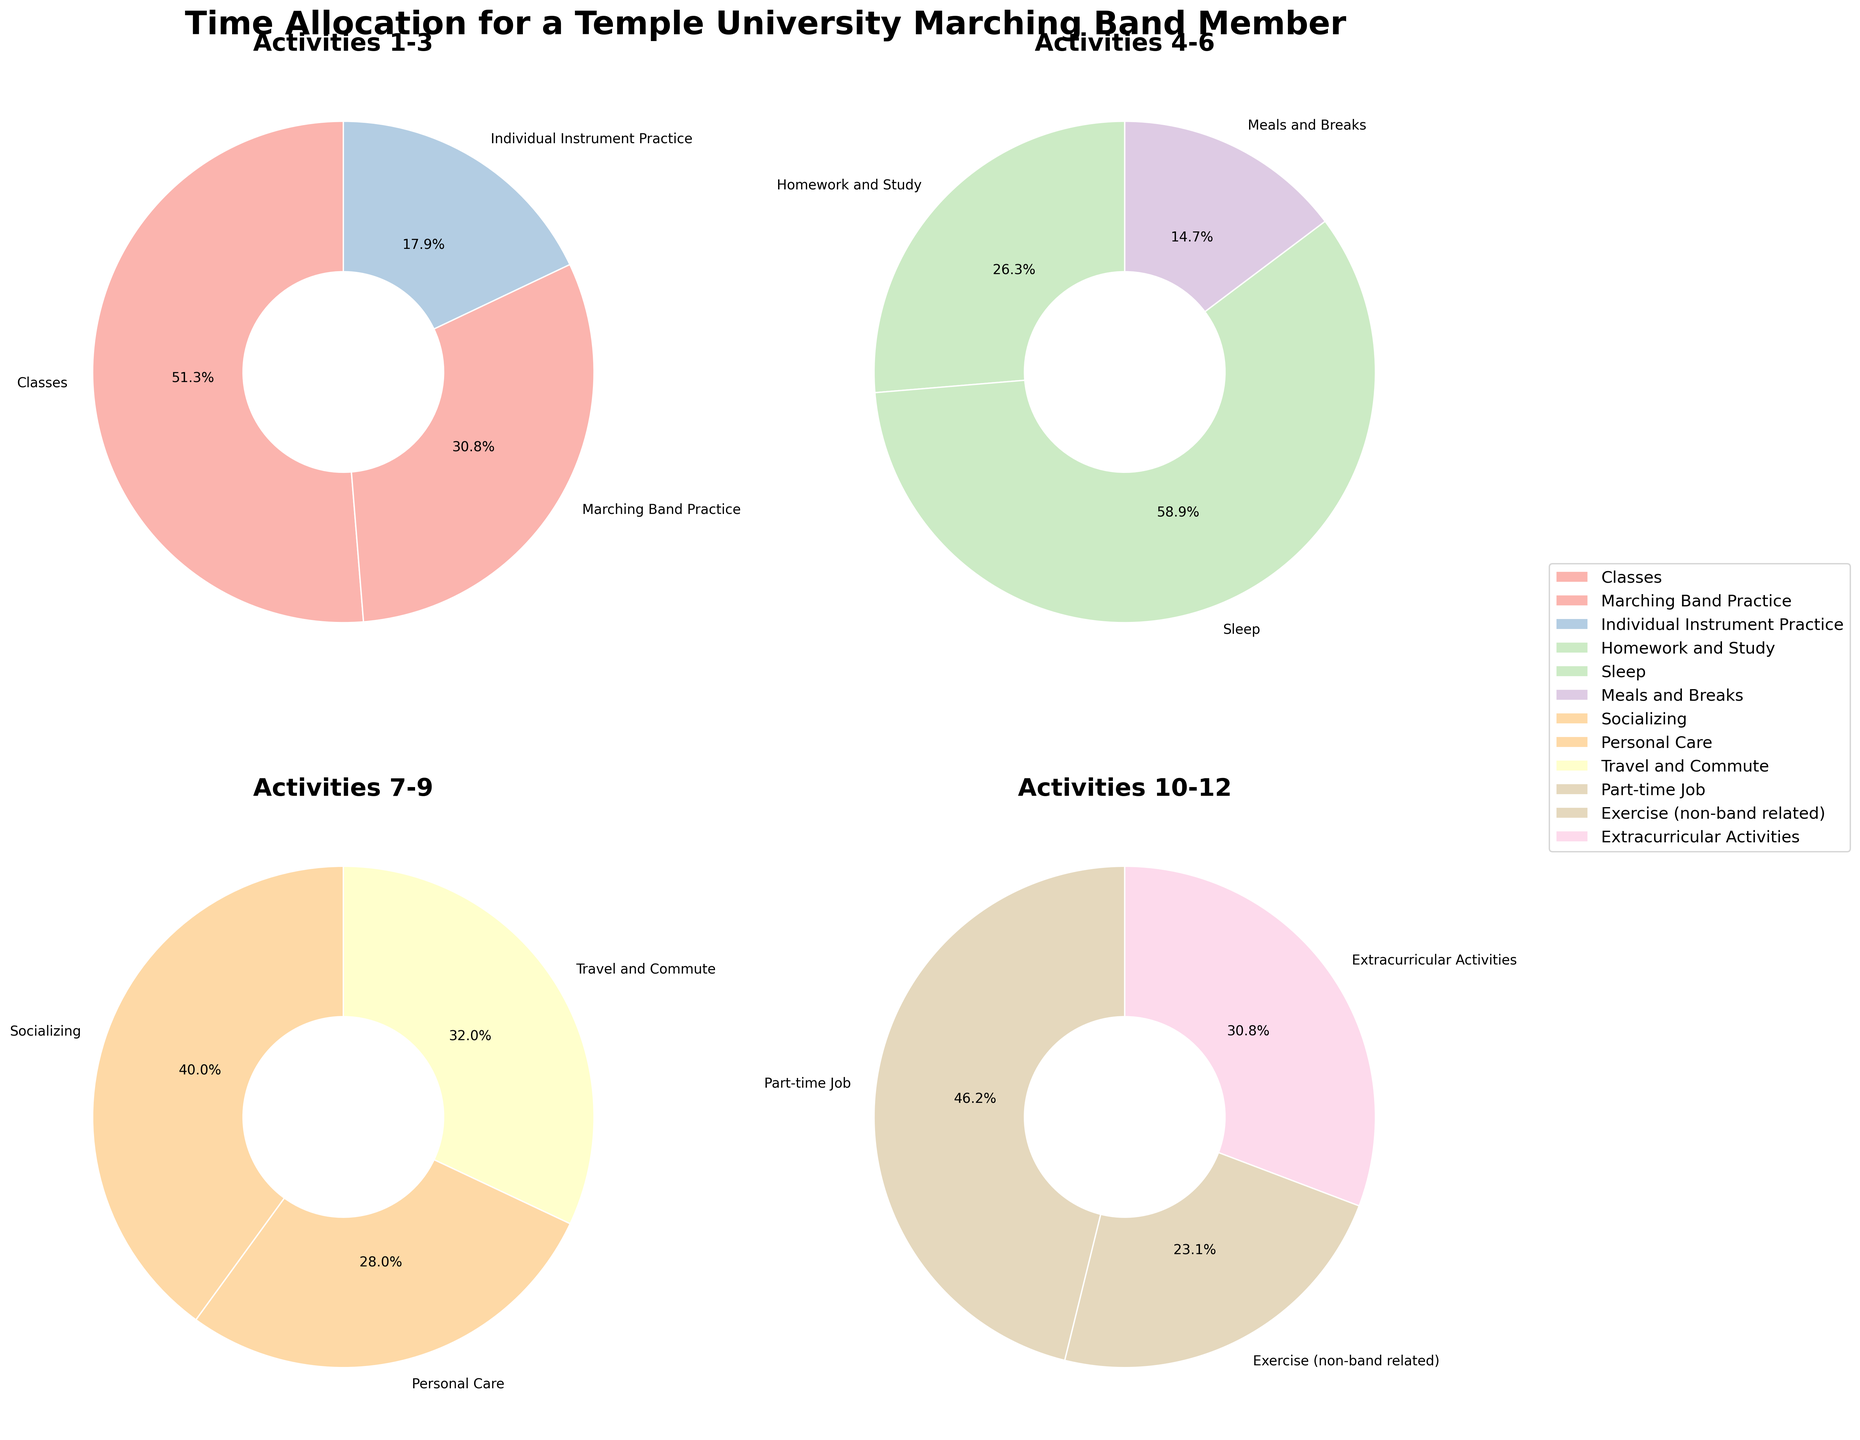What is the total amount of time spent on "Homework and Study" and "Classes" combined? To find the total amount of time spent on these activities, add the hours allocated to "Homework and Study" (25 hours) and "Classes" (20 hours). The sum is 25 + 20 = 45 hours.
Answer: 45 hours How many more hours are allocated to "Sleep" compared to "Homework and Study"? First, find the number of hours allocated to "Sleep" (56 hours). Then, find the number of hours for "Homework and Study" (25 hours). Subtract the latter from the former: 56 - 25 = 31 hours.
Answer: 31 hours Which activity takes up more time: "Marching Band Practice" or "Individual Instrument Practice"? Locate the allocated hours for both activities: "Marching Band Practice" is 12 hours and "Individual Instrument Practice" is 7 hours. Comparatively, "Marching Band Practice" has more hours.
Answer: Marching Band Practice What is the average amount of time allocated across "Meals and Breaks," "Socializing," and "Personal Care"? To find the average, first sum the hours of the three activities: "Meals and Breaks" is 14 hours, "Socializing" is 10 hours, and "Personal Care" is 7 hours. Their total is 14 + 10 + 7 = 31 hours. Then, divide by the number of activities (3): 31 / 3 ≈ 10.33 hours.
Answer: 10.33 hours What percentage of the total weekly hours is spent "Traveling and Commuting"? Calculate the total hours in a week: sum all the activity hours (20 + 12 + 7 + 25 + 56 + 14 + 10 + 7 + 8 + 6 + 3 + 4 + 6 + 2 = 180 hours). Then, divide the hours for "Travel and Commute" (8) by the total hours and multiply by 100: (8 / 180) * 100 ≈ 4.44%.
Answer: 4.44% If "Classes" and "Marching Band Practice" were combined into a single activity, would it exceed the time allocated to "Sleep"? By how many hours? Combine the hours for "Classes" (20) and "Marching Band Practice" (12): 20 + 12 = 32 hours. Compare to "Sleep" (56 hours). Since 56 > 32, the combined activity does not exceed the time for sleep. Subtract to find the difference: 56 - 32 = 24 hours.
Answer: No, by 24 hours Which wedge in the fourth pie chart represents "Extracurricular Activities"? In the fourth pie chart, the sections represent the last quarter segment of the list. Identify the segment without coding terms but noting the location visually: "Extracurricular Activities" is represented by the wedge specifically labeled with its name in the last part of the plot.
Answer: Identifiable by label What is the combined proportion of time spent on "Performances and Games" and "Uniform and Equipment Maintenance" in the fourth pie chart? The fourth chart shows the labeled proportions. "Performances and Games" is 6 hours, and "Uniform and Equipment Maintenance" is 2 hours. The combined time is 6 + 2 = 8 hours. To find the proportion of the total week's hours: (8 / 180) * 100 ≈ 4.44%.
Answer: 4.44% Does the activity "Part-time Job" require more or less time than the combination of "Exercise (non-band related)" and "Extracurricular Activities"? Hours for "Part-time Job" is 6. The combination of "Exercise (non-band related)" (3) and "Extracurricular Activities" (4) is 3 + 4 = 7. Since 6 < 7, "Part-time Job" requires less time.
Answer: Less Which chart would you find activities like "Meals and Breaks" and "Socializing"? Check the visual layout for "Meals and Breaks" and "Socializing." They fall in the range represented in the second pie chart when the list is divided into four.
Answer: Second chart 